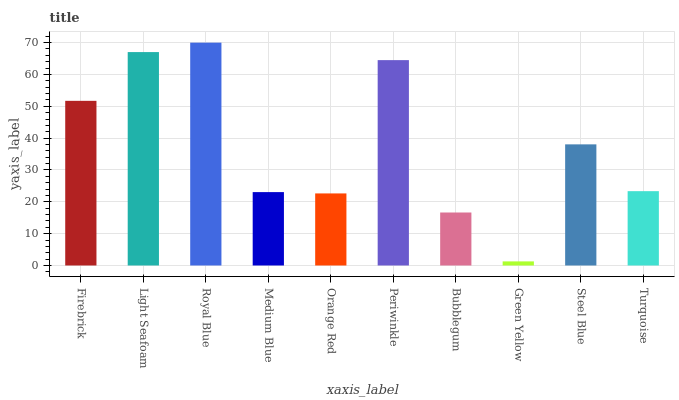Is Light Seafoam the minimum?
Answer yes or no. No. Is Light Seafoam the maximum?
Answer yes or no. No. Is Light Seafoam greater than Firebrick?
Answer yes or no. Yes. Is Firebrick less than Light Seafoam?
Answer yes or no. Yes. Is Firebrick greater than Light Seafoam?
Answer yes or no. No. Is Light Seafoam less than Firebrick?
Answer yes or no. No. Is Steel Blue the high median?
Answer yes or no. Yes. Is Turquoise the low median?
Answer yes or no. Yes. Is Green Yellow the high median?
Answer yes or no. No. Is Green Yellow the low median?
Answer yes or no. No. 